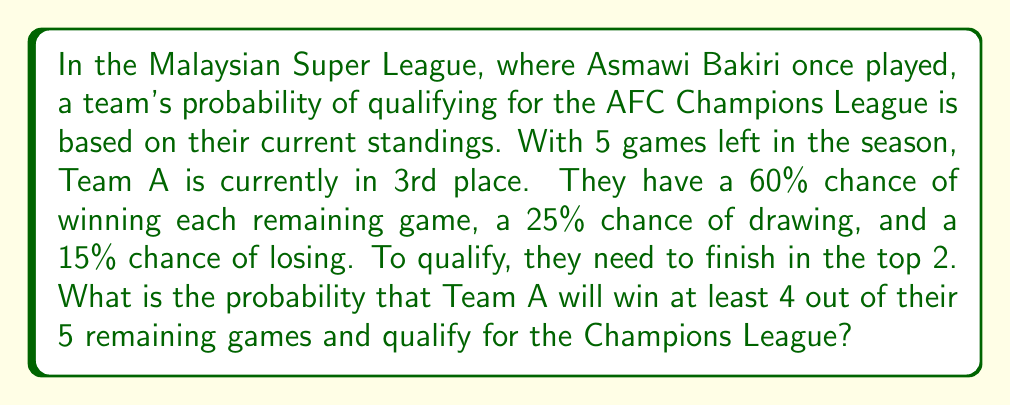Help me with this question. Let's approach this step-by-step:

1) First, we need to calculate the probability of winning at least 4 out of 5 games. This can be done using the binomial probability distribution.

2) The probability of success (winning a game) is 0.60, and we need to calculate P(X ≥ 4), where X is the number of wins.

3) P(X ≥ 4) = P(X = 4) + P(X = 5)

4) Using the binomial probability formula:

   $$P(X = k) = \binom{n}{k} p^k (1-p)^{n-k}$$

   Where n = 5 (total games), p = 0.60 (probability of winning a game)

5) For 4 wins:
   $$P(X = 4) = \binom{5}{4} (0.60)^4 (0.40)^1 = 5 \times 0.1296 \times 0.40 = 0.2592$$

6) For 5 wins:
   $$P(X = 5) = \binom{5}{5} (0.60)^5 (0.40)^0 = 1 \times 0.07776 = 0.07776$$

7) Therefore, P(X ≥ 4) = 0.2592 + 0.07776 = 0.33696

8) However, this is just the probability of winning at least 4 games. To qualify, they also need to finish in the top 2.

9) Let's assume that winning at least 4 games gives them an 80% chance of finishing in the top 2.

10) The final probability is thus:
    $$0.33696 \times 0.80 = 0.269568$$
Answer: $0.269568$ or approximately $26.96\%$ 